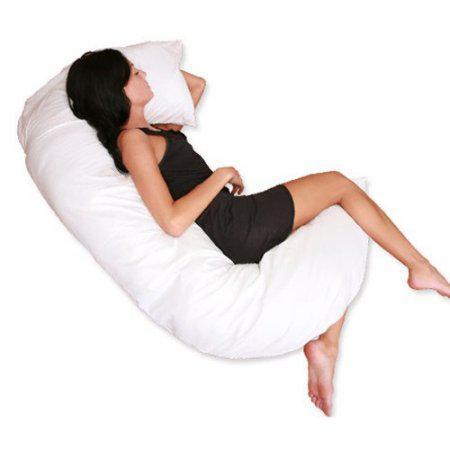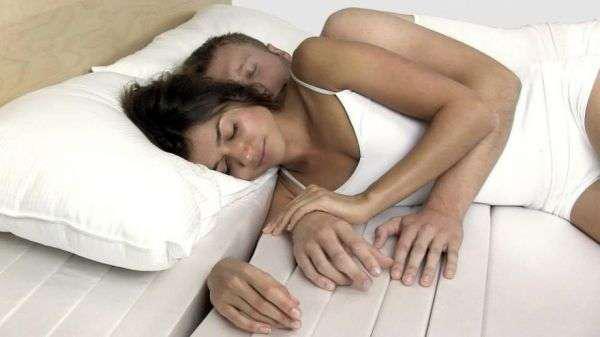The first image is the image on the left, the second image is the image on the right. Given the left and right images, does the statement "There are three people." hold true? Answer yes or no. Yes. The first image is the image on the left, the second image is the image on the right. Given the left and right images, does the statement "A woman is lying on her left side with a pillow as large as her." hold true? Answer yes or no. Yes. 